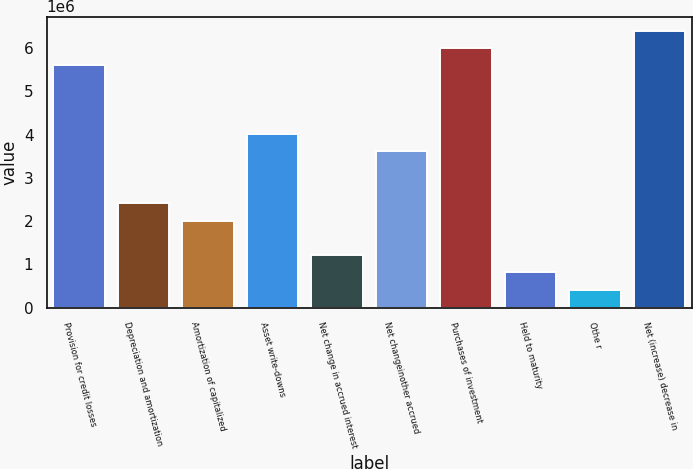Convert chart to OTSL. <chart><loc_0><loc_0><loc_500><loc_500><bar_chart><fcel>Provision for credit losses<fcel>Depreciation and amortization<fcel>Amortization of capitalized<fcel>Asset write-downs<fcel>Net change in accrued interest<fcel>Net changeinother accrued<fcel>Purchases of investment<fcel>Held to maturity<fcel>Othe r<fcel>Net (increase) decrease in<nl><fcel>5.61023e+06<fcel>2.41556e+06<fcel>2.01622e+06<fcel>4.01289e+06<fcel>1.21755e+06<fcel>3.61356e+06<fcel>6.00956e+06<fcel>818218<fcel>418883<fcel>6.4089e+06<nl></chart> 